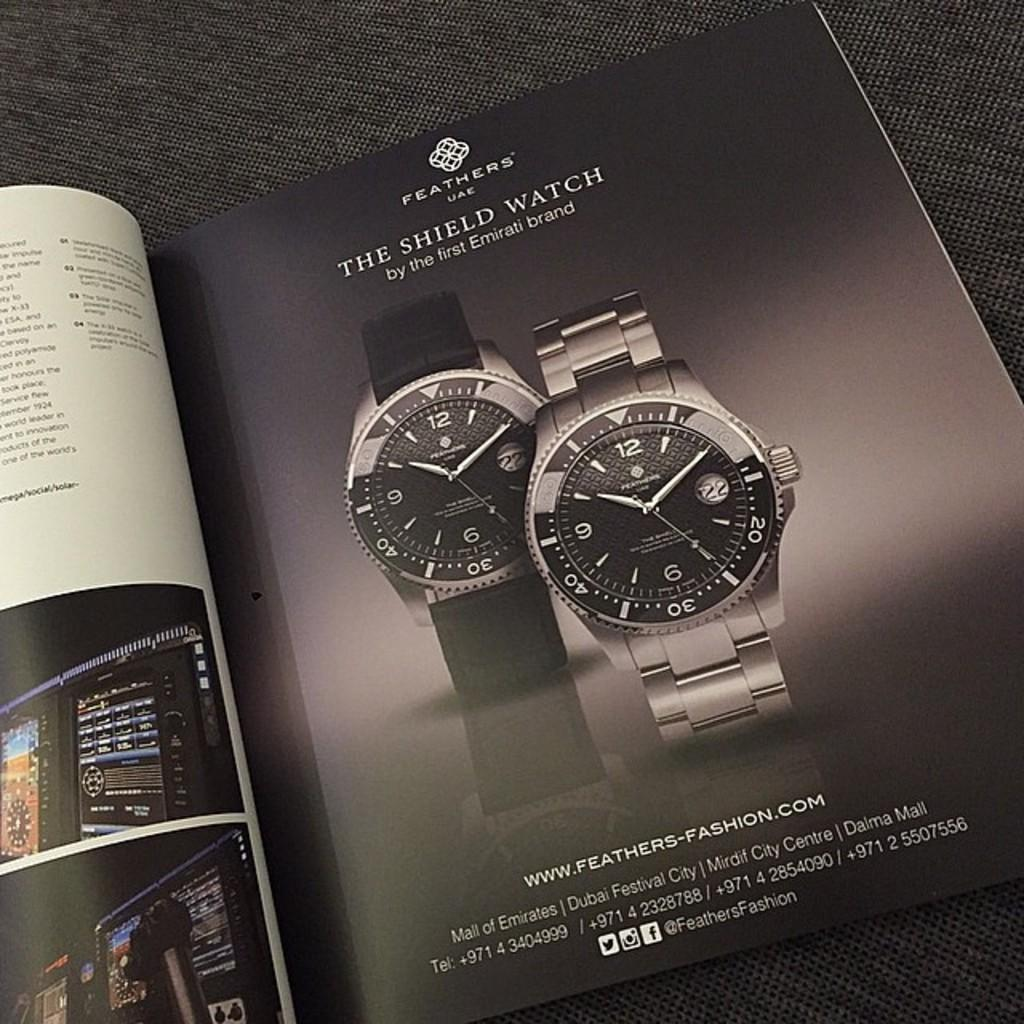<image>
Summarize the visual content of the image. To find out more about The Shield Watch go to www.feathers-fashion.com. 